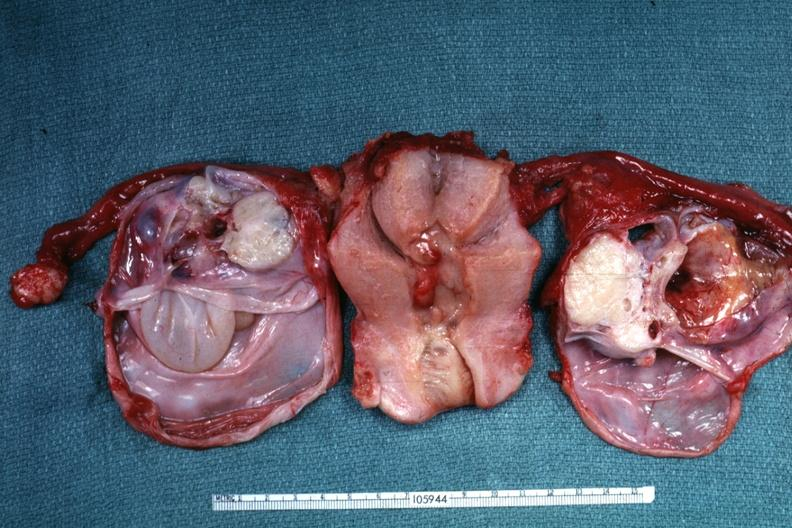have ovaries been cut to show multiloculated nature of tumor masses?
Answer the question using a single word or phrase. Yes 